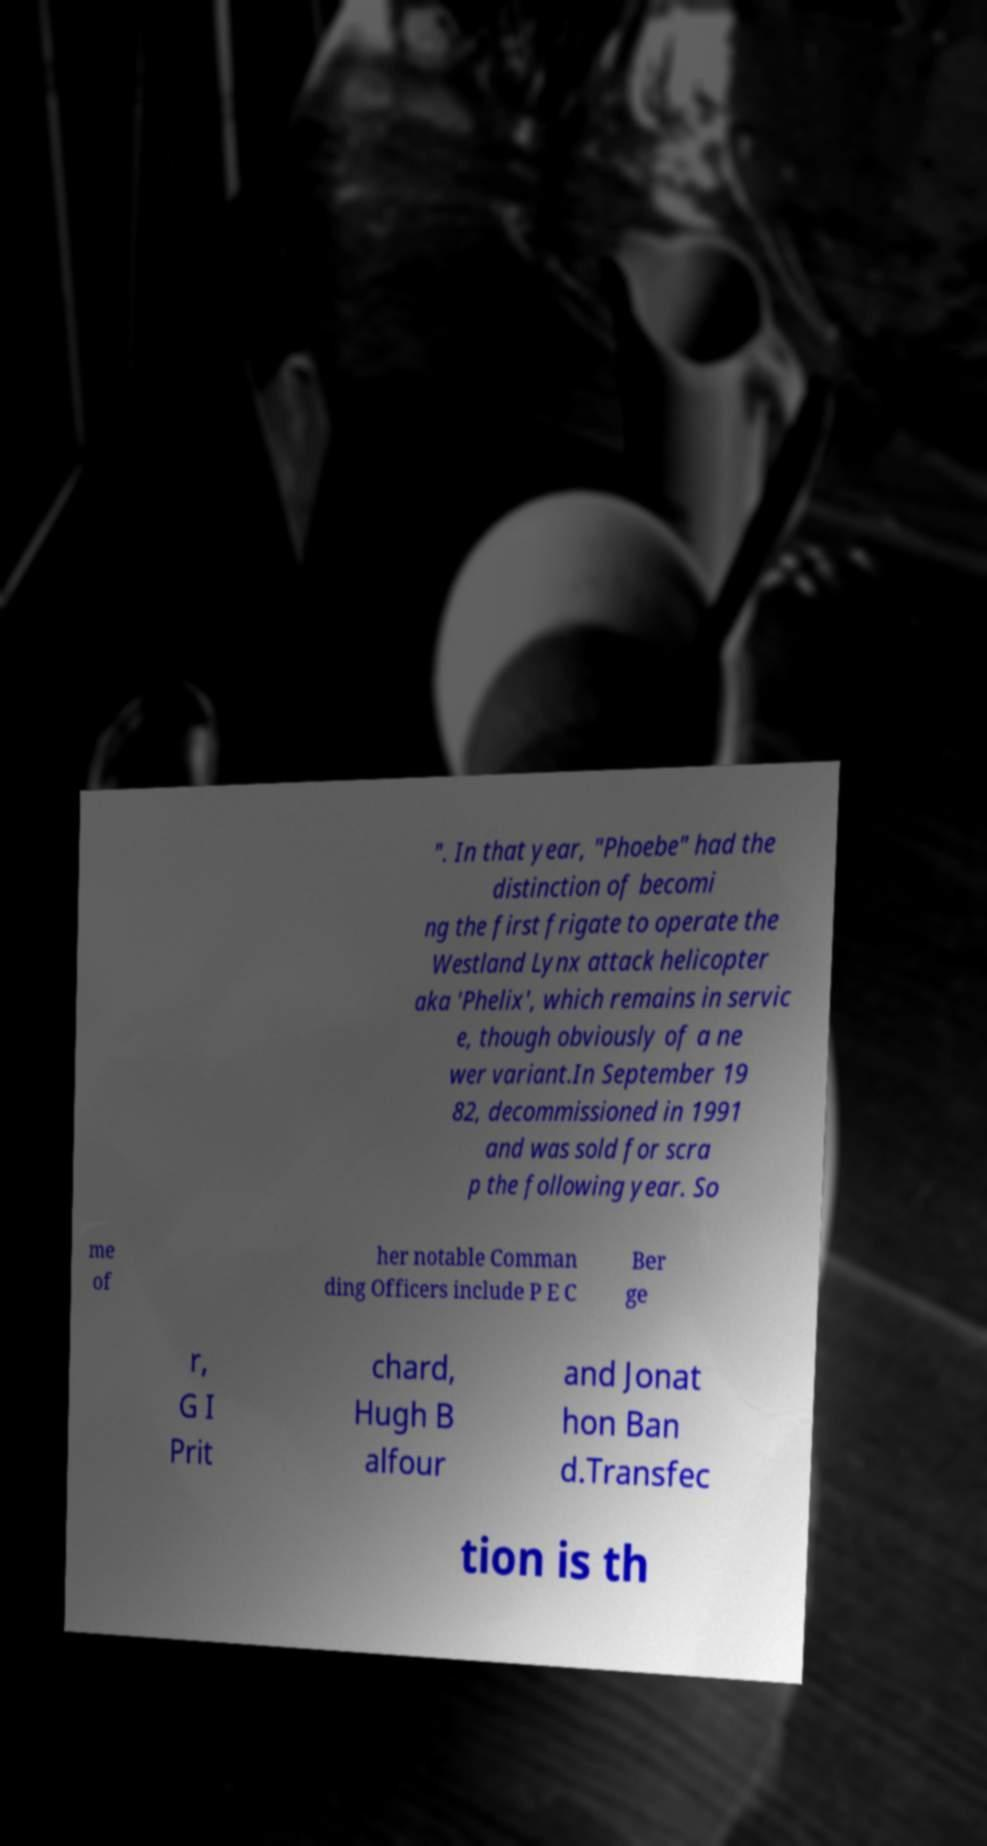Please identify and transcribe the text found in this image. ". In that year, "Phoebe" had the distinction of becomi ng the first frigate to operate the Westland Lynx attack helicopter aka 'Phelix', which remains in servic e, though obviously of a ne wer variant.In September 19 82, decommissioned in 1991 and was sold for scra p the following year. So me of her notable Comman ding Officers include P E C Ber ge r, G I Prit chard, Hugh B alfour and Jonat hon Ban d.Transfec tion is th 